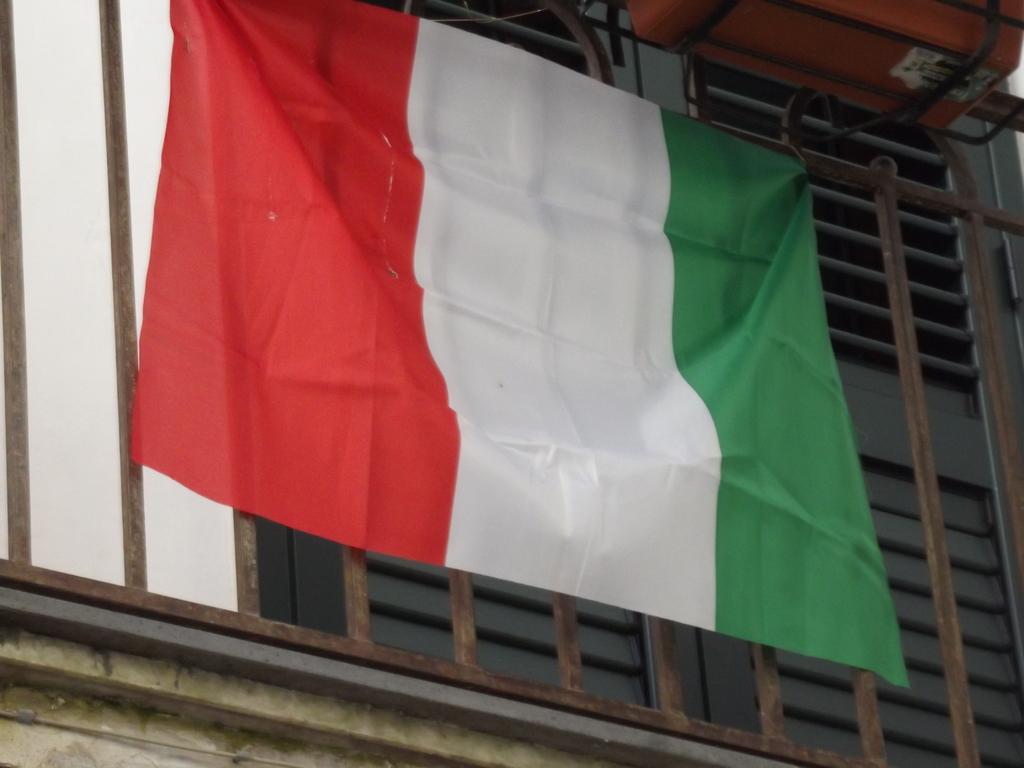Can you describe this image briefly? In this image we can see a flag to the grills. 